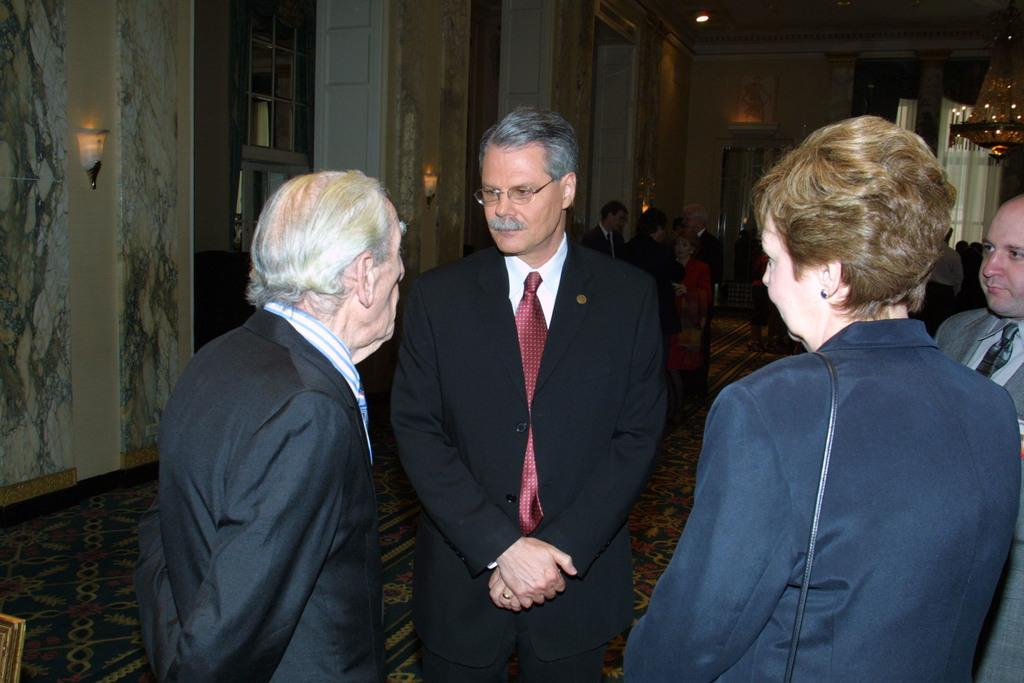What is happening in the image? There are people standing in the image. Can you describe the clothing of the people? The people are wearing different color dresses. What can be seen in the background of the image? There are windows, lights, and a wall visible in the background. Are there any pets visible in the image? No, there are no pets present in the image. 